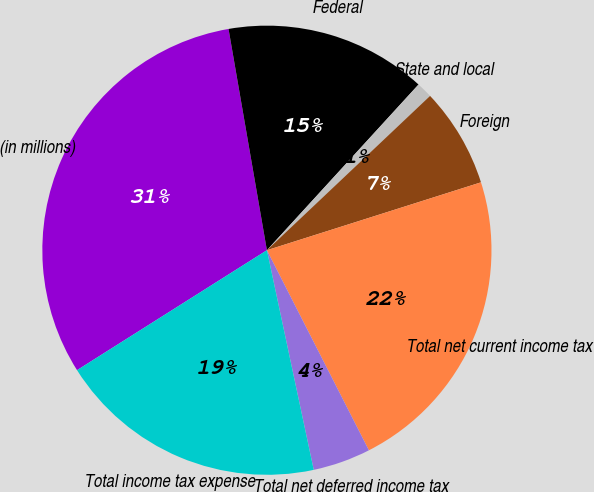Convert chart. <chart><loc_0><loc_0><loc_500><loc_500><pie_chart><fcel>(in millions)<fcel>Federal<fcel>State and local<fcel>Foreign<fcel>Total net current income tax<fcel>Total net deferred income tax<fcel>Total income tax expense<nl><fcel>31.24%<fcel>14.53%<fcel>1.15%<fcel>7.17%<fcel>22.39%<fcel>4.16%<fcel>19.38%<nl></chart> 